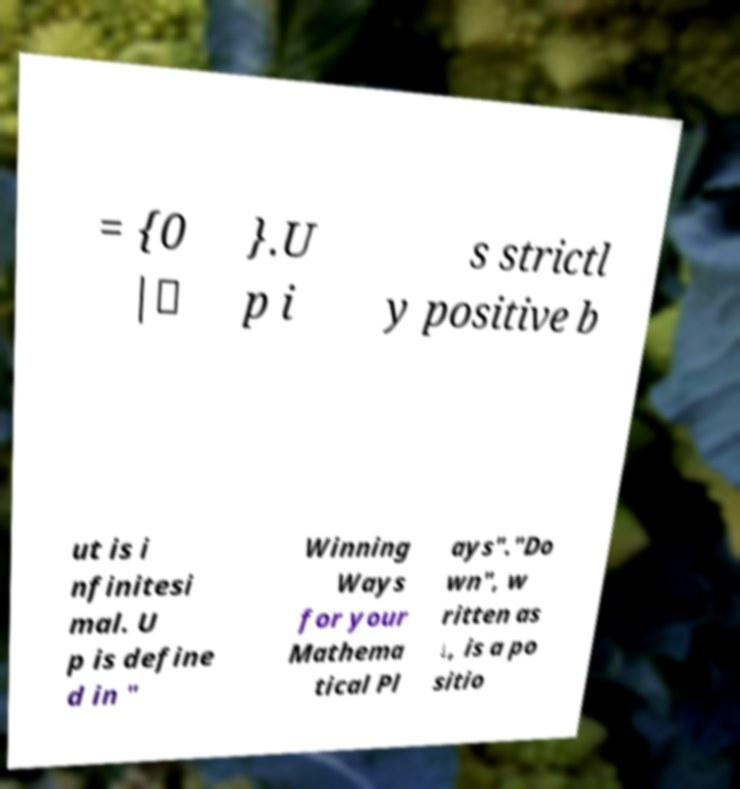What messages or text are displayed in this image? I need them in a readable, typed format. = {0 |∗ }.U p i s strictl y positive b ut is i nfinitesi mal. U p is define d in " Winning Ways for your Mathema tical Pl ays"."Do wn", w ritten as ↓, is a po sitio 